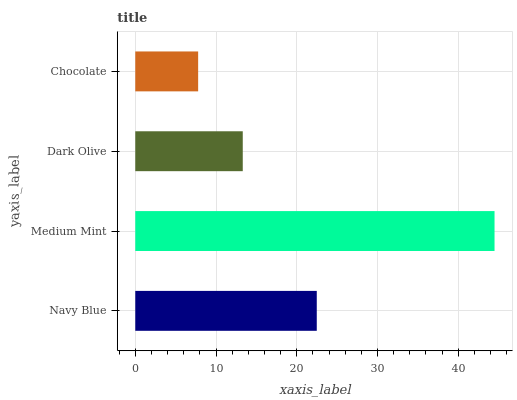Is Chocolate the minimum?
Answer yes or no. Yes. Is Medium Mint the maximum?
Answer yes or no. Yes. Is Dark Olive the minimum?
Answer yes or no. No. Is Dark Olive the maximum?
Answer yes or no. No. Is Medium Mint greater than Dark Olive?
Answer yes or no. Yes. Is Dark Olive less than Medium Mint?
Answer yes or no. Yes. Is Dark Olive greater than Medium Mint?
Answer yes or no. No. Is Medium Mint less than Dark Olive?
Answer yes or no. No. Is Navy Blue the high median?
Answer yes or no. Yes. Is Dark Olive the low median?
Answer yes or no. Yes. Is Medium Mint the high median?
Answer yes or no. No. Is Medium Mint the low median?
Answer yes or no. No. 